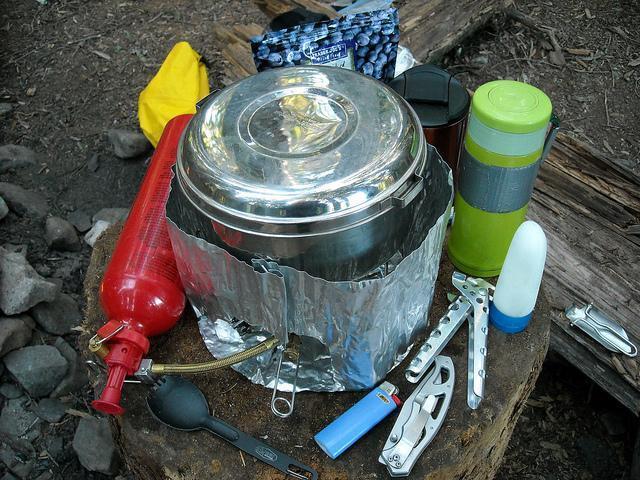How many bottles are there?
Give a very brief answer. 2. How many people are in this photo?
Give a very brief answer. 0. 